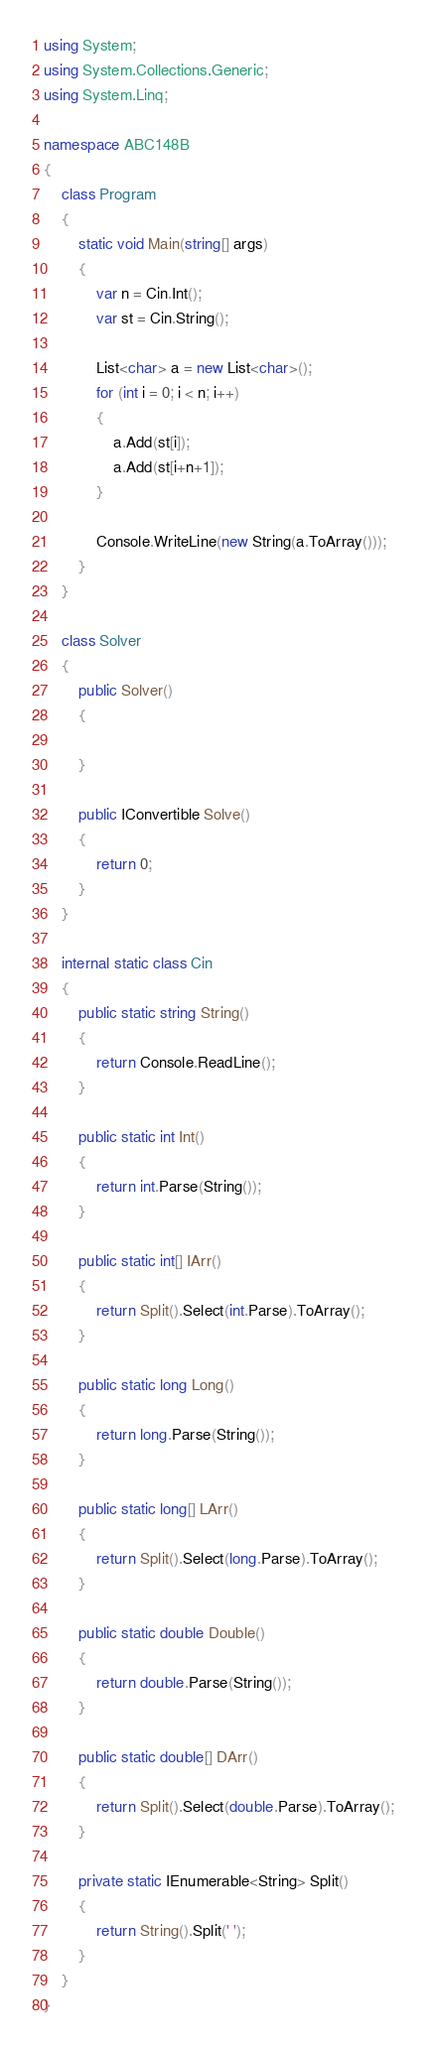Convert code to text. <code><loc_0><loc_0><loc_500><loc_500><_C#_>using System;
using System.Collections.Generic;
using System.Linq;

namespace ABC148B
{
    class Program
    {
        static void Main(string[] args)
        {
            var n = Cin.Int();
            var st = Cin.String();

            List<char> a = new List<char>();
            for (int i = 0; i < n; i++)
            {
                a.Add(st[i]);
                a.Add(st[i+n+1]);
            }

            Console.WriteLine(new String(a.ToArray()));
        }
    }

    class Solver
    {
        public Solver()
        {

        }

        public IConvertible Solve()
        {
            return 0;
        }
    }

    internal static class Cin
    {
        public static string String()
        {
            return Console.ReadLine();
        }

        public static int Int()
        {
            return int.Parse(String());
        }

        public static int[] IArr()
        {
            return Split().Select(int.Parse).ToArray();
        }

        public static long Long()
        {
            return long.Parse(String());
        }

        public static long[] LArr()
        {
            return Split().Select(long.Parse).ToArray();
        }

        public static double Double()
        {
            return double.Parse(String());
        }

        public static double[] DArr()
        {
            return Split().Select(double.Parse).ToArray();
        }

        private static IEnumerable<String> Split()
        {
            return String().Split(' ');
        }
    }
}</code> 